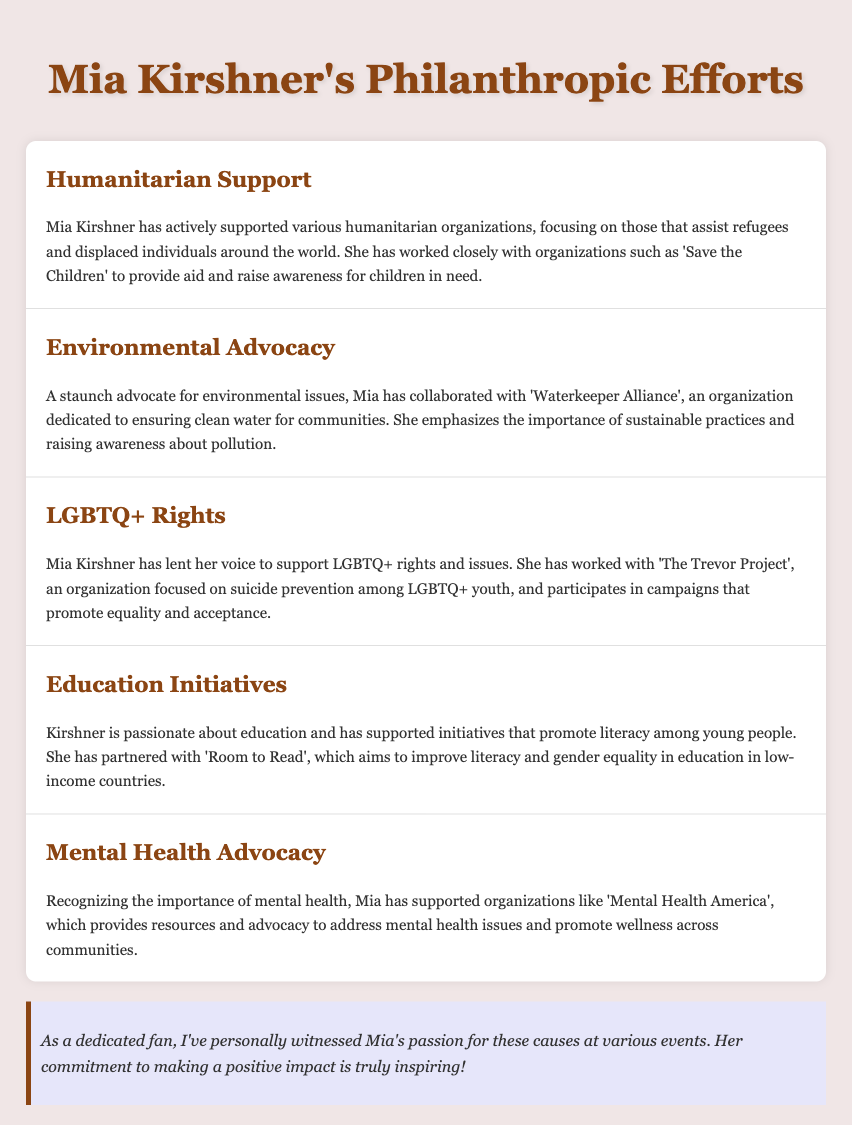What organization does Mia work with for humanitarian support? The document mentions that Mia has worked closely with 'Save the Children' for humanitarian support.
Answer: Save the Children Which environmental organization is Mia associated with? The document states that Mia has collaborated with 'Waterkeeper Alliance' for environmental advocacy.
Answer: Waterkeeper Alliance What cause is addressed by The Trevor Project? The document indicates that The Trevor Project focuses on suicide prevention among LGBTQ+ youth.
Answer: Suicide prevention What is the primary focus of Room to Read? According to the document, Room to Read aims to improve literacy and gender equality in education in low-income countries.
Answer: Literacy and gender equality Which organization does Mia support for mental health? The document states that Mia has supported 'Mental Health America' for mental health advocacy.
Answer: Mental Health America Why is Mia's commitment to philanthropy noteworthy? The document notes that her passion for these causes is personally witnessed at various events, making her commitment inspiring.
Answer: Inspiring commitment 